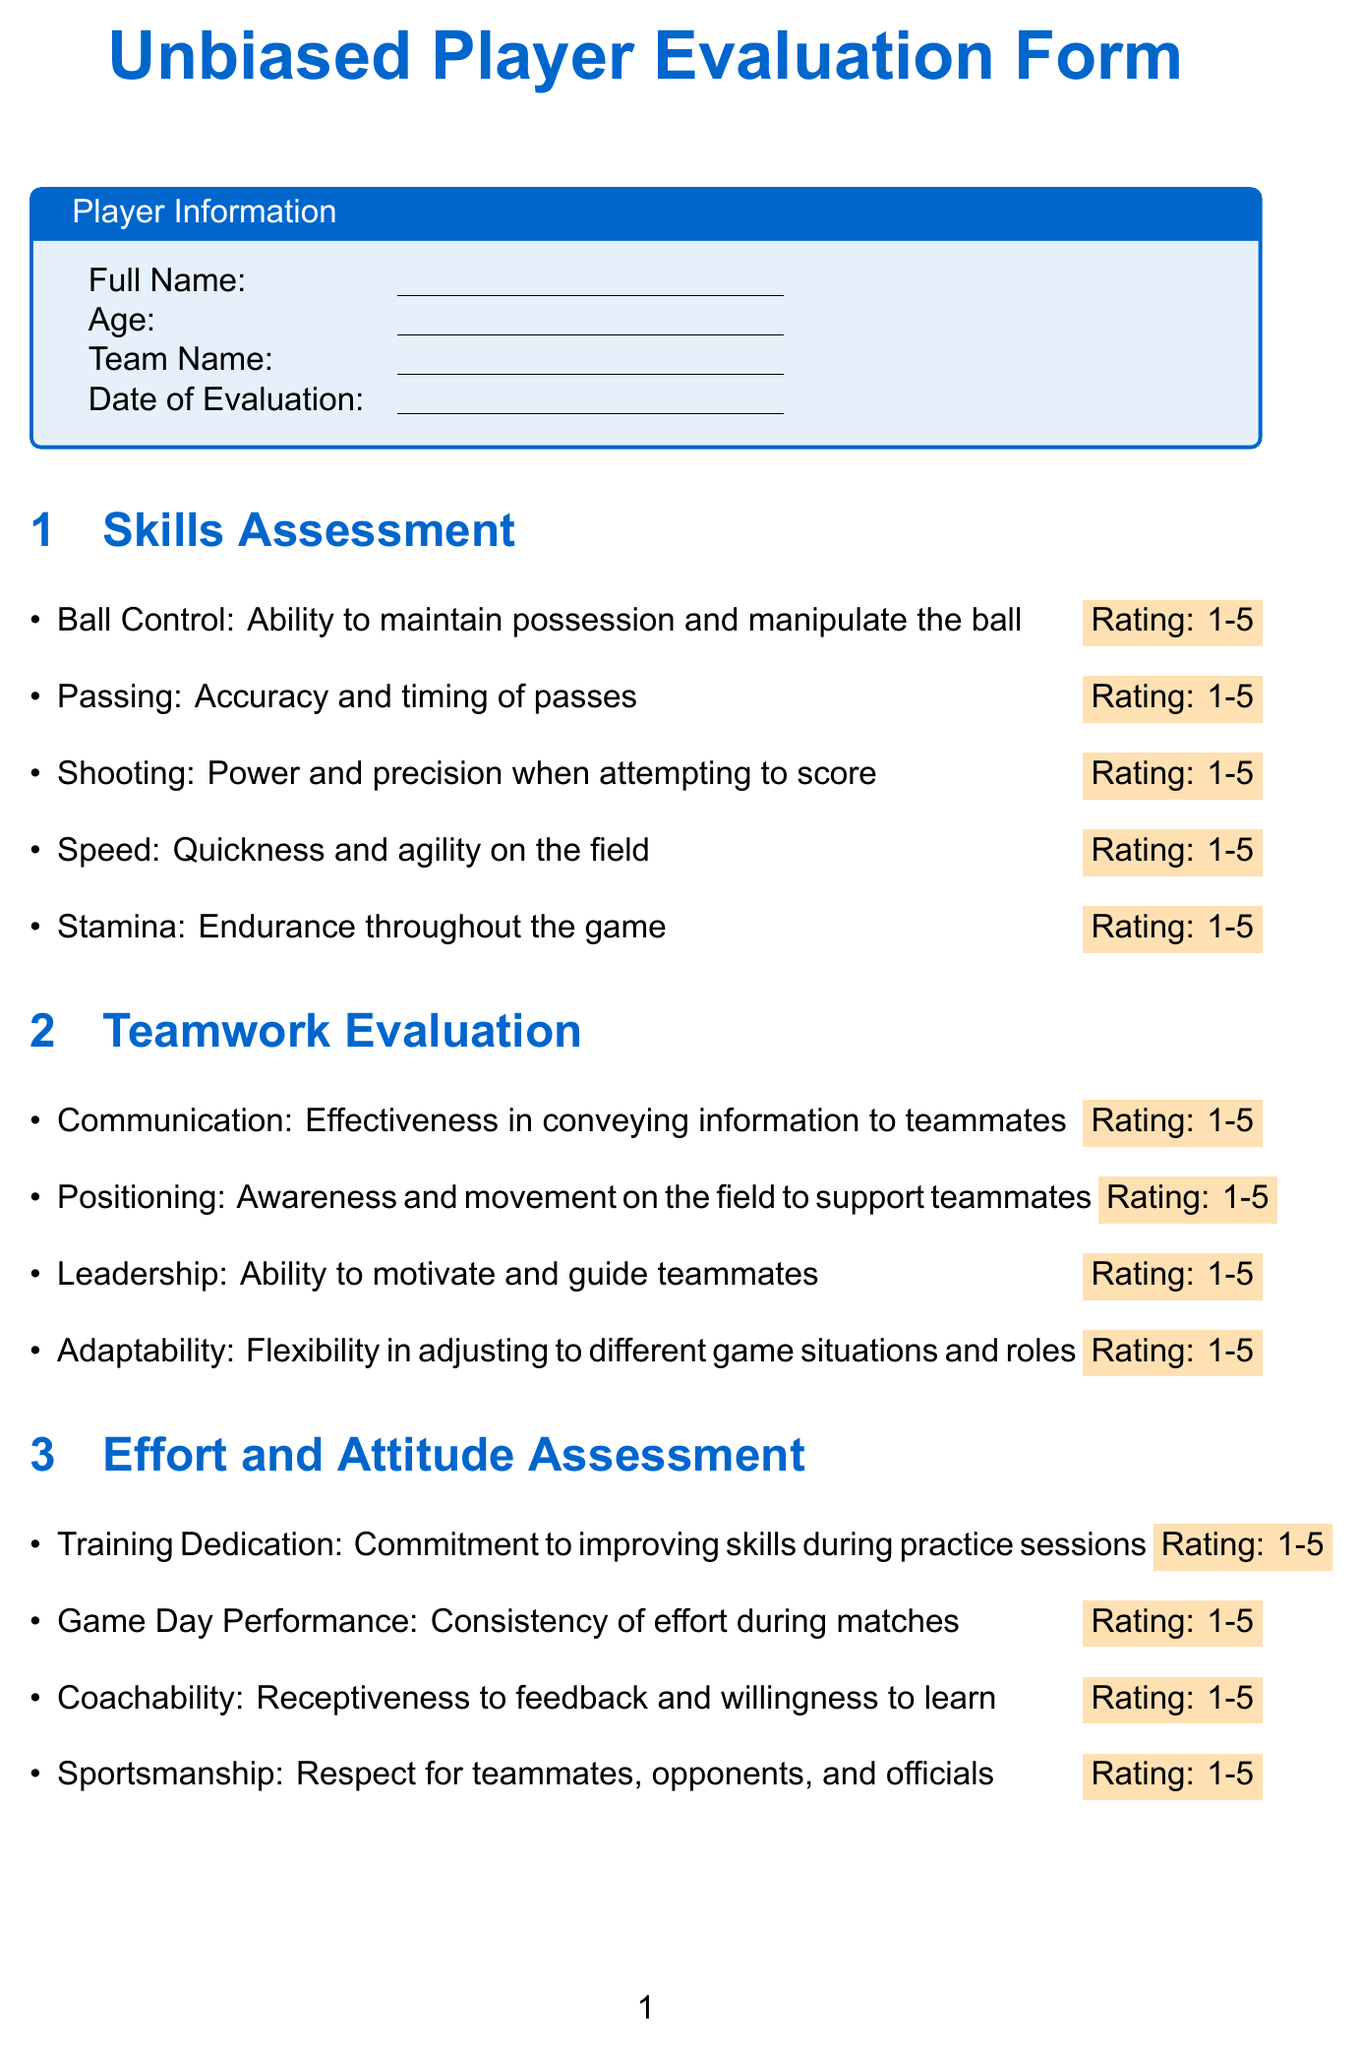What is the title of the form? The title of the form is presented at the top of the document, highlighting its purpose and focus.
Answer: Unbiased Player Evaluation Form What is the maximum character limit for the overall player assessment? The document specifies a character limit for the summary section, ensuring concise feedback is provided.
Answer: 500 characters Who should sign the evaluation form? The document includes a section for identification of the evaluator, indicating who is responsible for completing the assessment.
Answer: Evaluator's Signature What is assessed in the "Skills Assessment" section? This section covers various technical abilities relevant to all players, ensuring all contributions are evaluated equally.
Answer: Ball Control, Passing, Shooting, Speed, Stamina What does the fair play statement emphasize? The fair play statement reflects the document's commitment to impartiality and equal evaluation for all players.
Answer: Assess players based on individual merits How many categories are there under the teamwork evaluation? The document organizes evaluations into distinct categories to ensure comprehensive feedback is provided on teamwork aspects.
Answer: Four categories What is the purpose of the "Effort and Attitude Assessment" section? This section is designed to evaluate the player's commitment and attitude toward their performance, reflecting their dedication to the team.
Answer: Commitment to improving skills What areas are included in the Teamwork Evaluation? The areas assessed reflect the player's abilities to collaborate effectively within the team setting, crucial for overall success.
Answer: Communication, Positioning, Leadership, Adaptability 